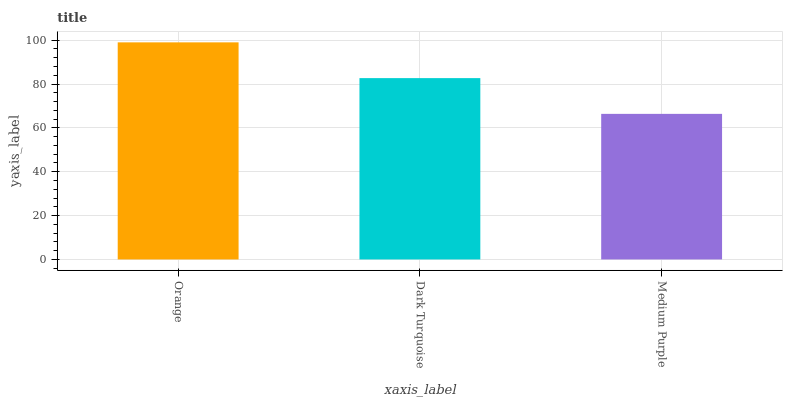Is Medium Purple the minimum?
Answer yes or no. Yes. Is Orange the maximum?
Answer yes or no. Yes. Is Dark Turquoise the minimum?
Answer yes or no. No. Is Dark Turquoise the maximum?
Answer yes or no. No. Is Orange greater than Dark Turquoise?
Answer yes or no. Yes. Is Dark Turquoise less than Orange?
Answer yes or no. Yes. Is Dark Turquoise greater than Orange?
Answer yes or no. No. Is Orange less than Dark Turquoise?
Answer yes or no. No. Is Dark Turquoise the high median?
Answer yes or no. Yes. Is Dark Turquoise the low median?
Answer yes or no. Yes. Is Orange the high median?
Answer yes or no. No. Is Medium Purple the low median?
Answer yes or no. No. 